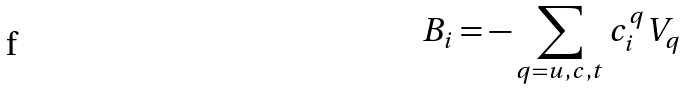<formula> <loc_0><loc_0><loc_500><loc_500>B _ { i } = - \sum _ { q = u , c , t } c _ { i } ^ { q } V _ { q }</formula> 